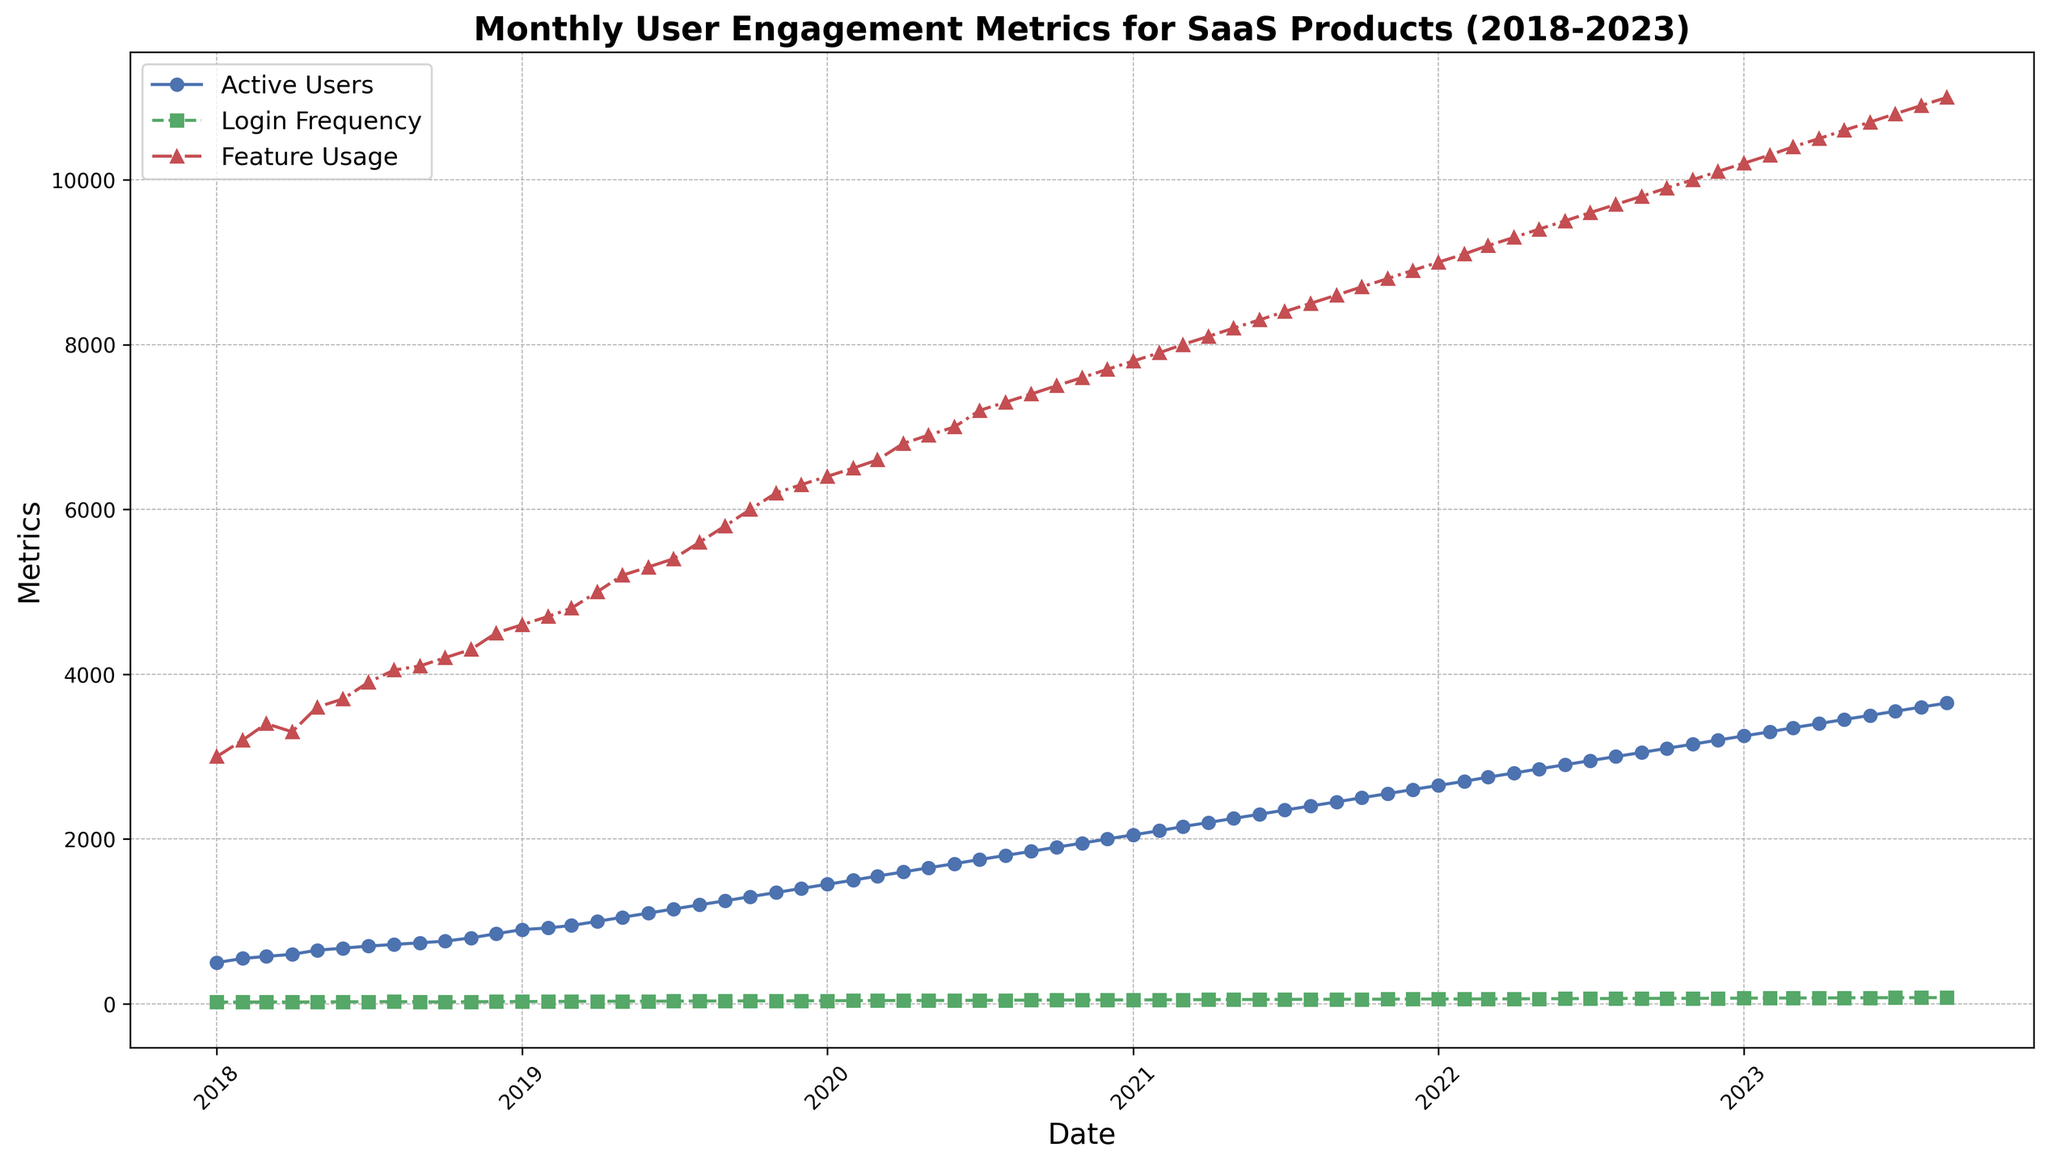What is the overall trend of Active Users from 2018 to 2023? Reviewing the plot, it is evident that the number of Active Users shows a steady increase over the five years. The line gradually rises from the beginning of 2018 to the end of 2023.
Answer: Increasing trend At which point do Active Users, Login Frequency, and Feature Usage intersect or come closest to each other? By closely examining the plot, one can observe that around October 2019, Active Users, Login Frequency, and Feature Usage are closest to each other since their values converge near this point.
Answer: October 2019 Between January 2019 and January 2020, how much did the Login Frequency increase? The Login Frequency in January 2019 was 27, and in January 2020, it was 37. The difference between these two points is 37 - 27 = 10.
Answer: 10 Which metric shows the most significant increase over the given period? Comparing the slopes of the lines representing Active Users, Login Frequency, and Feature Usage, the steepest slope is seen in Active Users, indicating the most significant increase over the period.
Answer: Active Users What is the difference in Feature Usage between the start and end of the dataset? The Feature Usage at the start (January 2018) is 3000, while at the end (September 2023), it is 11000. The difference is 11000 - 3000 = 8000.
Answer: 8000 Which month in 2020 showed the highest jump in Active Users compared to the previous month? The plot shows that from March 2020 (Active Users = 1550) to April 2020 (Active Users = 1600), there was a notable jump of 1600 - 1550 = 50 Active Users, the highest within 2020.
Answer: April 2020 How does Login Frequency in December 2021 compare with that in January 2021? From the plot, the Login Frequency for January 2021 is 47, and for December 2021, it is 57. Therefore, December’s Login Frequency is higher by 57 - 47 = 10.
Answer: 10 higher On what date did Feature Usage reach 5000 for the first time? Reviewing the plot, Feature Usage reached 5000 in April 2019 for the first time.
Answer: April 2019 Which metric remained relatively stable between October 2021 and November 2021? By observing the plot closely, it is evident that the Feature Usage metric showed minimal change, remaining relatively stable between October 2021 (8700) and November 2021 (8800).
Answer: Feature Usage What can you infer about the user engagement based on the trend of all three metrics? All three metrics, Active Users, Login Frequency, and Feature Usage, show an upward trend over the five-year span, indicating an overall increase in user engagement with the SaaS product. This suggests improving engagement and likely satisfaction among users.
Answer: Increasing user engagement 